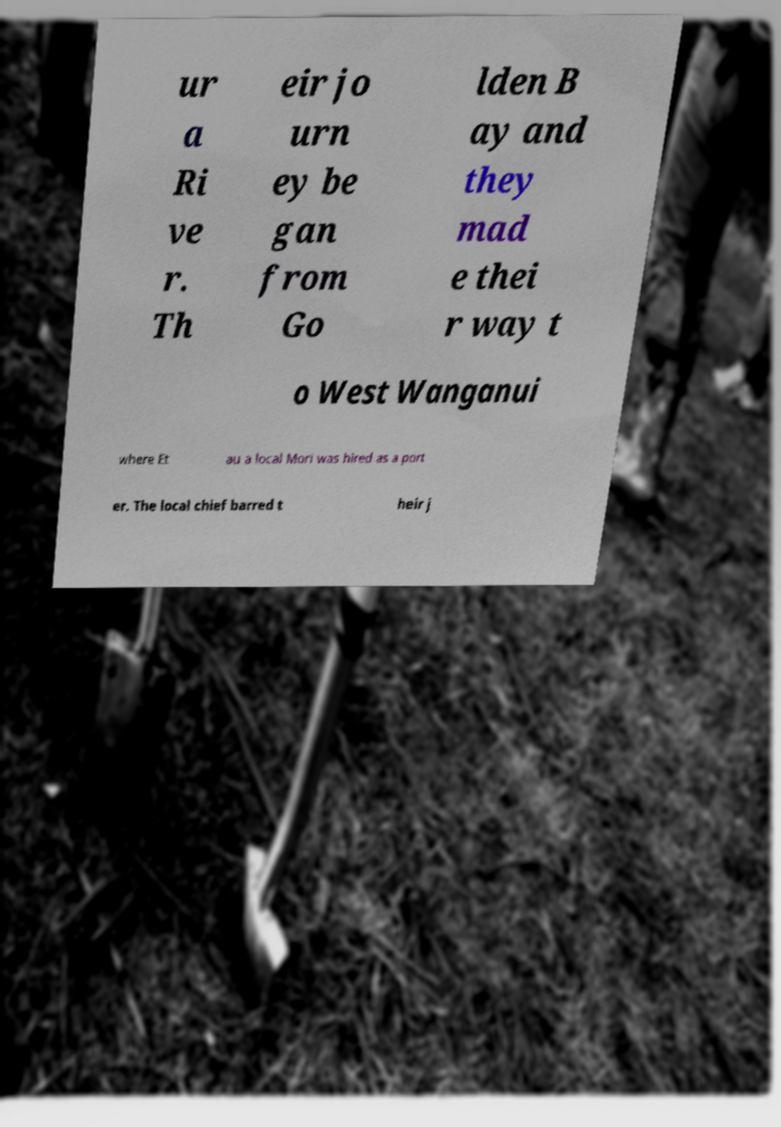I need the written content from this picture converted into text. Can you do that? ur a Ri ve r. Th eir jo urn ey be gan from Go lden B ay and they mad e thei r way t o West Wanganui where Et au a local Mori was hired as a port er. The local chief barred t heir j 